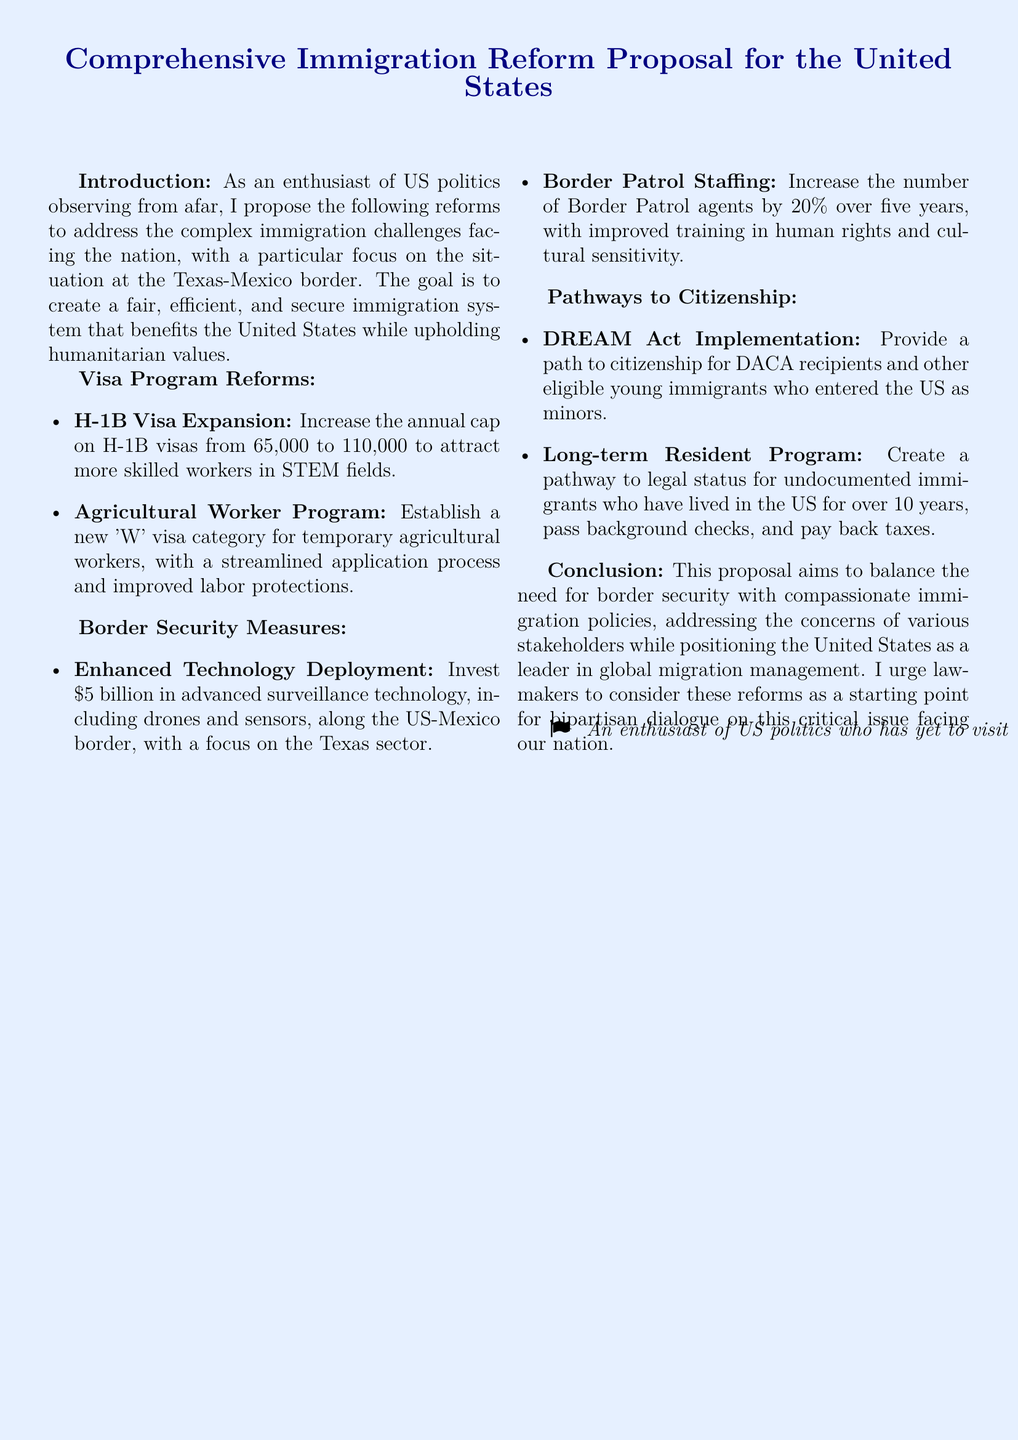What is the proposed annual cap on H-1B visas? The document states an increase from 65,000 to 110,000 for H-1B visas.
Answer: 110,000 What new visa category is proposed for agricultural workers? The document mentions the establishment of a new 'W' visa category for temporary agricultural workers.
Answer: 'W' visa How much investment is suggested for advanced surveillance technology? The proposal includes investing $5 billion in advanced surveillance technology.
Answer: $5 billion What percentage increase in Border Patrol staffing is proposed? The document states a proposed increase of 20% in the number of Border Patrol agents.
Answer: 20% What is one specific group mentioned that would benefit from a path to citizenship? The document references DACA recipients as a specific group for citizenship pathways.
Answer: DACA recipients What is the time requirement for undocumented immigrants to be eligible for the Long-term Resident Program? The document specifies that undocumented immigrants must have lived in the US for over 10 years to qualify.
Answer: Over 10 years Which act is proposed to be implemented for young immigrants? The document mentions the DREAM Act as part of the reforms for young immigrants.
Answer: DREAM Act What overall goal does the proposal aim to balance? The proposal aims to balance the need for border security with compassionate immigration policies.
Answer: Border security and compassionate immigration policies 